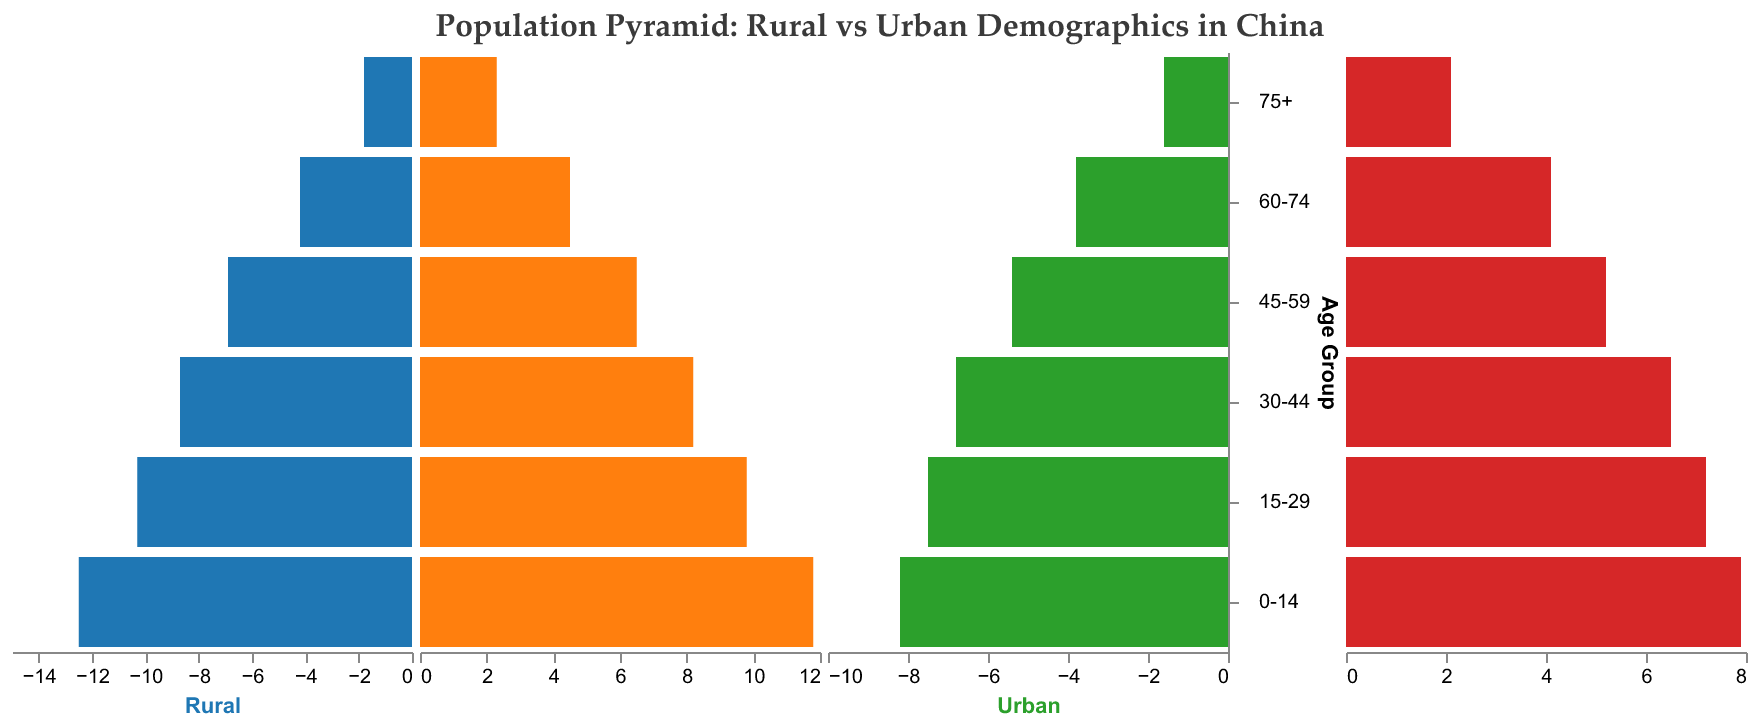What is the title of the population pyramid? The title of the plot is written at the top center of the figure.
Answer: Population Pyramid: Rural vs Urban Demographics in China Which age group has the highest percentage of rural males? The highest bar on the rural male side represents the age group with the highest percentage.
Answer: 0-14 In the 45-59 age group, which has a higher percentage: rural females or urban females? By comparing the lengths of the bars for rural females and urban females in the 45-59 age group, we see that the rural female bar is longer.
Answer: Rural females What is the percentage difference between rural males and urban males in the 30-44 age group? The percentage for rural males is 8.7 and for urban males is 6.8. Difference = 8.7 - 6.8.
Answer: 1.9 Which gender has a higher population percentage in urban areas for the 60-74 age group? By comparing the lengths of the bars for urban males and urban females in the 60-74 age group, the urban female bar is slightly longer.
Answer: Urban females Describe the trend in population percentages for rural males across different age groups. As the age group increases from 0-14 to 75+, the percentage of rural males generally decreases.
Answer: Decreasing trend For the 75+ age group, which segment has the smallest population percentage? The smallest bar among the four categories in the 75+ age group can be observed directly.
Answer: Urban males Calculate the average percentage of rural females across all age groups. Sum the percentages for rural females across all age groups: (11.8 + 9.8 + 8.2 + 6.5 + 4.5 + 2.3) and then divide by 6.
Answer: 7.18 How does the population composition in the 0-14 age group compare between rural and urban areas? Compare the bars for rural males, rural females, urban males, and urban females in the 0-14 age group; rural areas have higher percentages for both genders compared to urban areas.
Answer: Higher in rural areas Which age group has the highest combined urban female and urban male population percentage? For each age group, sum the percentages of urban females and urban males, and find the highest sum.
Answer: 0-14 